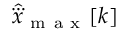Convert formula to latex. <formula><loc_0><loc_0><loc_500><loc_500>\hat { \dddot { x } } _ { m a x } [ k ]</formula> 